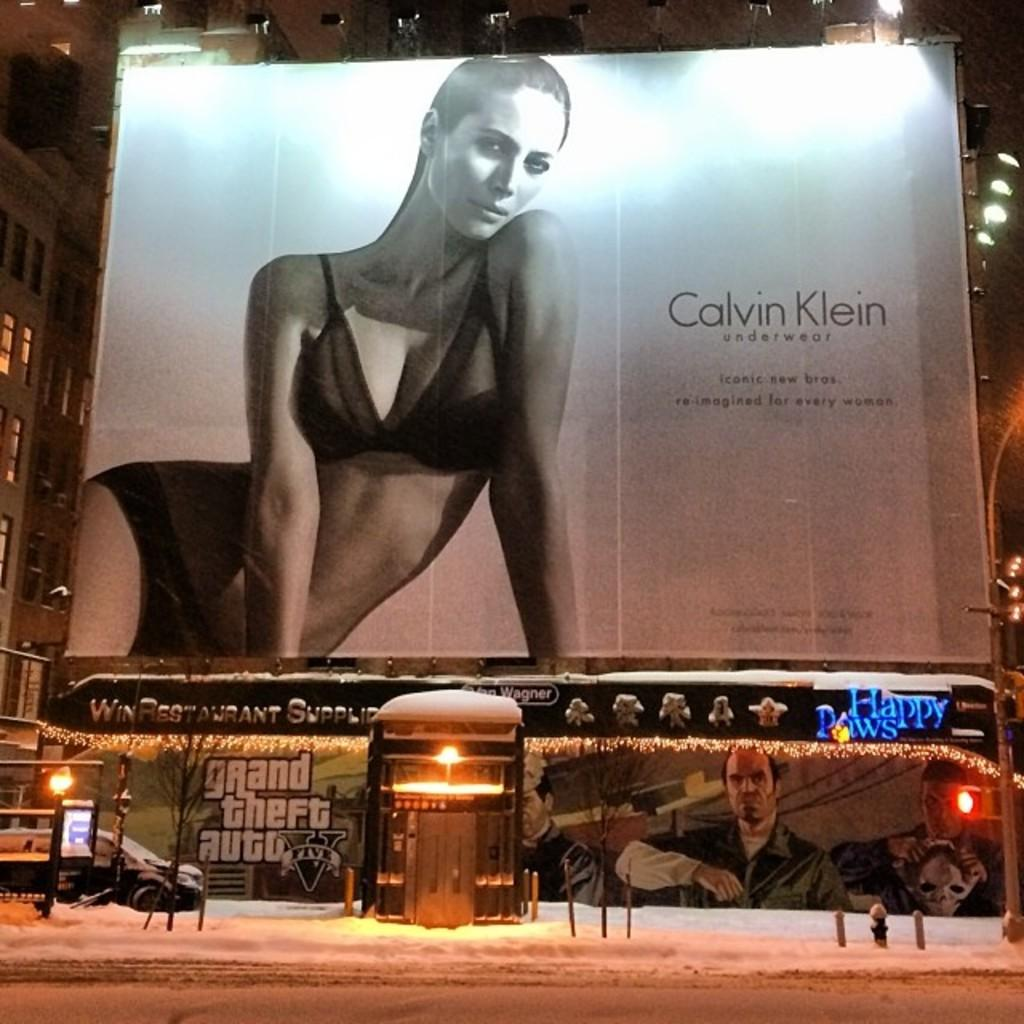<image>
Describe the image concisely. A Calvin Klein underwear billboard sits over an advertisement for Grand Theft Auto five. 